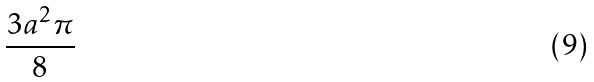<formula> <loc_0><loc_0><loc_500><loc_500>\frac { 3 a ^ { 2 } \pi } { 8 }</formula> 